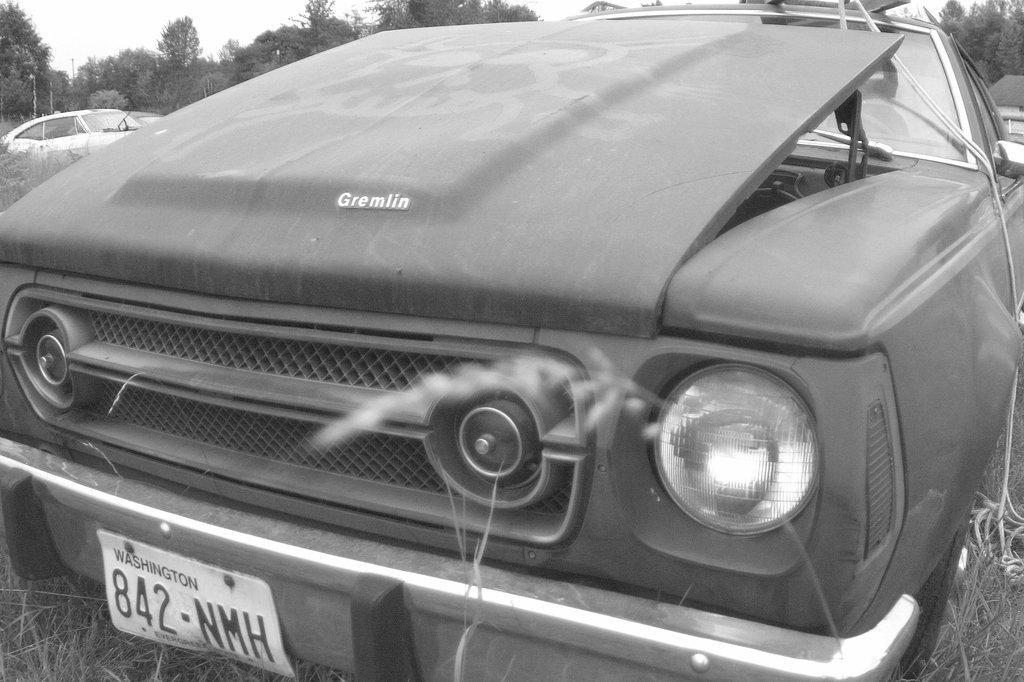What is the color scheme of the image? The image is black and white. What can be seen in the foreground of the image? There is a vehicle with a number plate in the image. What is visible in the background of the image? There are trees and another vehicle in the background of the image. What type of meat is being served by the pig in the image? There is no pig or meat present in the image; it features a vehicle with a number plate and trees in the background. 